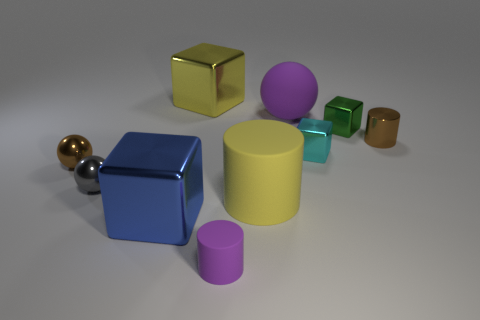What is the shape of the big object that is right of the tiny purple cylinder and behind the brown sphere?
Provide a succinct answer. Sphere. Is the number of yellow blocks behind the small matte thing the same as the number of small red balls?
Your response must be concise. No. What number of objects are either big purple things or tiny things behind the small gray sphere?
Offer a terse response. 5. Is there a cyan thing of the same shape as the gray shiny object?
Your answer should be compact. No. Are there the same number of brown metallic cylinders that are behind the purple rubber sphere and cyan metallic cubes that are left of the yellow rubber cylinder?
Provide a short and direct response. Yes. Is there any other thing that has the same size as the cyan cube?
Your answer should be very brief. Yes. What number of cyan things are tiny rubber cylinders or tiny matte spheres?
Provide a short and direct response. 0. What number of yellow cubes have the same size as the cyan thing?
Your answer should be very brief. 0. What color is the large object that is both behind the yellow rubber cylinder and to the right of the small rubber cylinder?
Give a very brief answer. Purple. Are there more cubes that are behind the small green metal object than large blue metal cylinders?
Provide a succinct answer. Yes. 